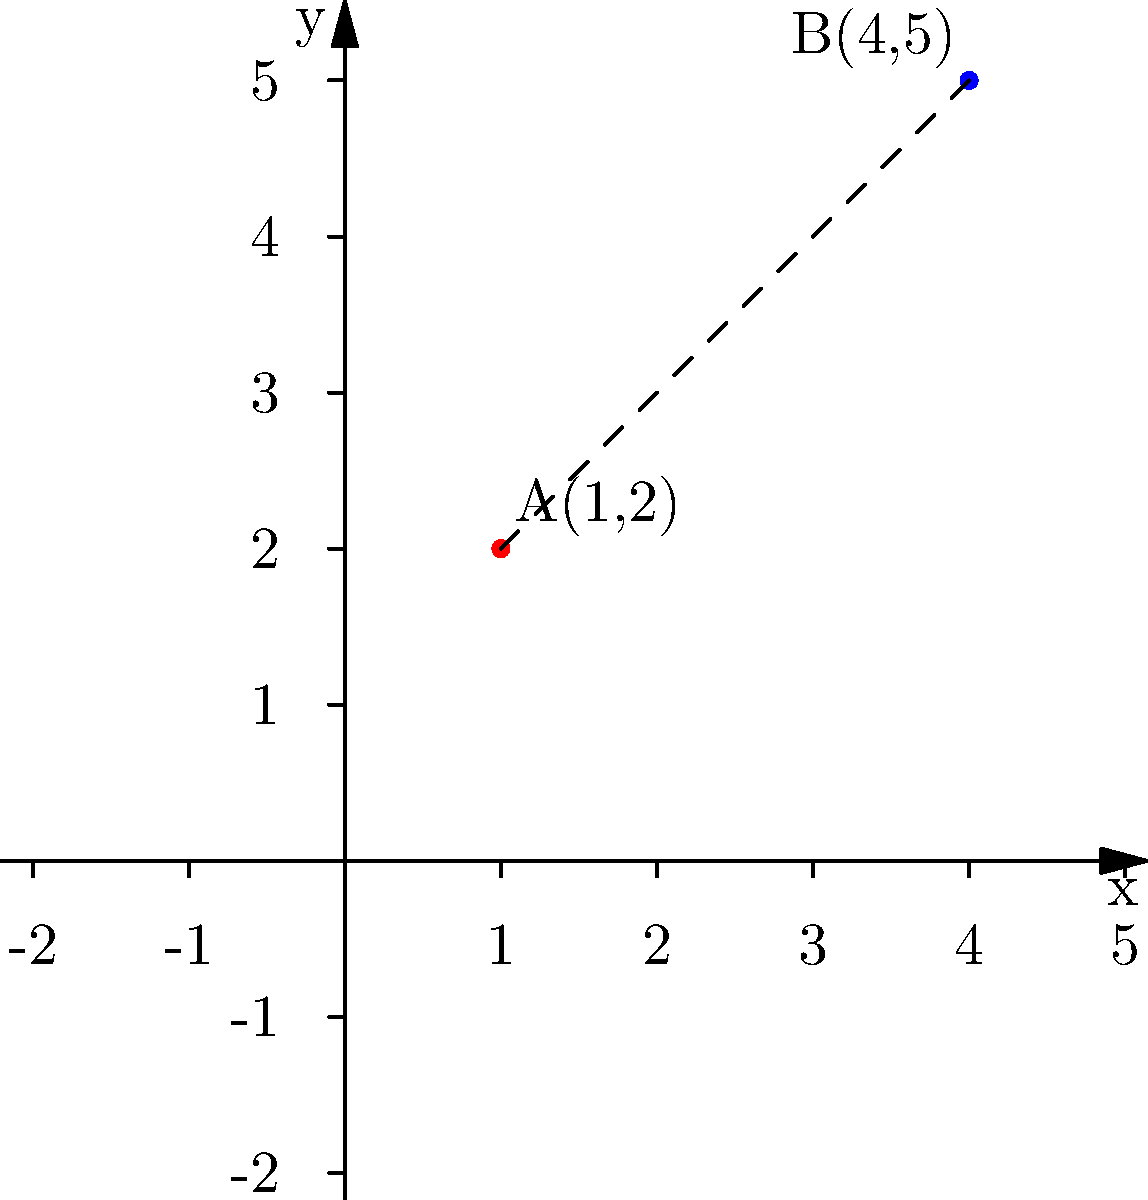You're planning a romantic picnic at point A(1,2) in a local park. Your date suggests meeting at point B(4,5) instead. To ensure you have enough time to walk between these locations, you need to calculate the distance between points A and B. Using the distance formula, determine the distance between these two points on the coordinate plane. Let's approach this step-by-step:

1) The distance formula between two points $(x_1, y_1)$ and $(x_2, y_2)$ is:

   $$d = \sqrt{(x_2 - x_1)^2 + (y_2 - y_1)^2}$$

2) In this case, we have:
   Point A: $(x_1, y_1) = (1, 2)$
   Point B: $(x_2, y_2) = (4, 5)$

3) Let's substitute these values into the formula:

   $$d = \sqrt{(4 - 1)^2 + (5 - 2)^2}$$

4) Simplify inside the parentheses:

   $$d = \sqrt{3^2 + 3^2}$$

5) Calculate the squares:

   $$d = \sqrt{9 + 9}$$

6) Add inside the square root:

   $$d = \sqrt{18}$$

7) Simplify the square root:

   $$d = 3\sqrt{2}$$

Therefore, the distance between points A and B is $3\sqrt{2}$ units.
Answer: $3\sqrt{2}$ units 